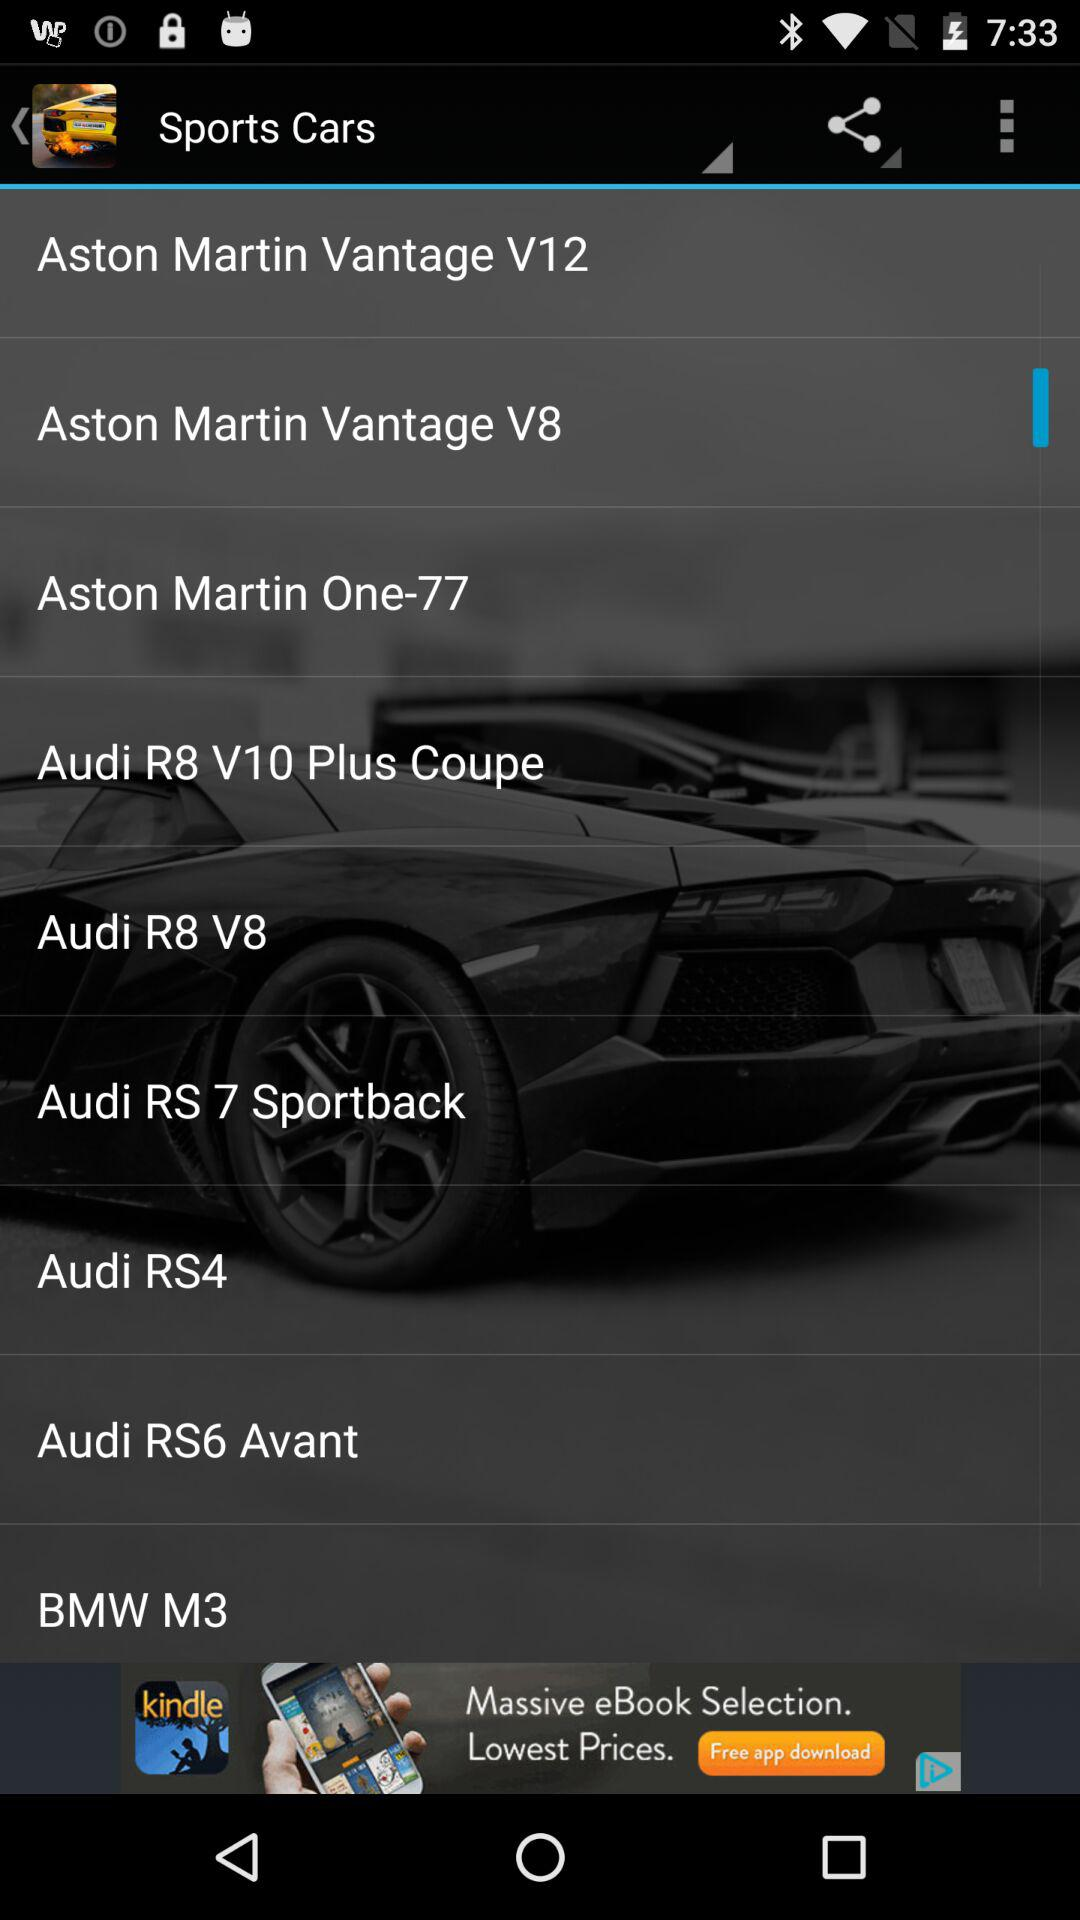What is the model of the Vantage car? The models of the Vantage cars are "Aston Martin Vantage V12" and "Aston Martin Vantage V8". 